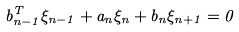<formula> <loc_0><loc_0><loc_500><loc_500>b ^ { T } _ { n - 1 } \xi _ { n - 1 } + a _ { n } \xi _ { n } + b _ { n } \xi _ { n + 1 } = 0</formula> 